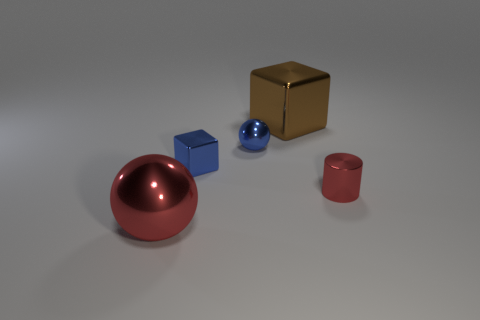Add 5 big metal objects. How many objects exist? 10 Subtract all large red metallic things. Subtract all large metallic blocks. How many objects are left? 3 Add 3 metallic cubes. How many metallic cubes are left? 5 Add 5 tiny gray cubes. How many tiny gray cubes exist? 5 Subtract 1 blue blocks. How many objects are left? 4 Subtract all cylinders. How many objects are left? 4 